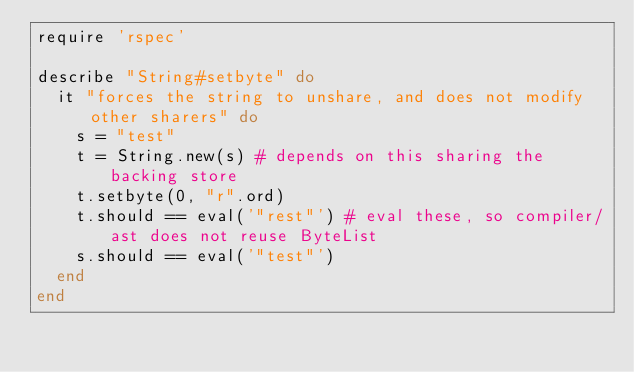Convert code to text. <code><loc_0><loc_0><loc_500><loc_500><_Ruby_>require 'rspec'

describe "String#setbyte" do
  it "forces the string to unshare, and does not modify other sharers" do
    s = "test"
    t = String.new(s) # depends on this sharing the backing store
    t.setbyte(0, "r".ord)
    t.should == eval('"rest"') # eval these, so compiler/ast does not reuse ByteList
    s.should == eval('"test"')
  end
end
</code> 